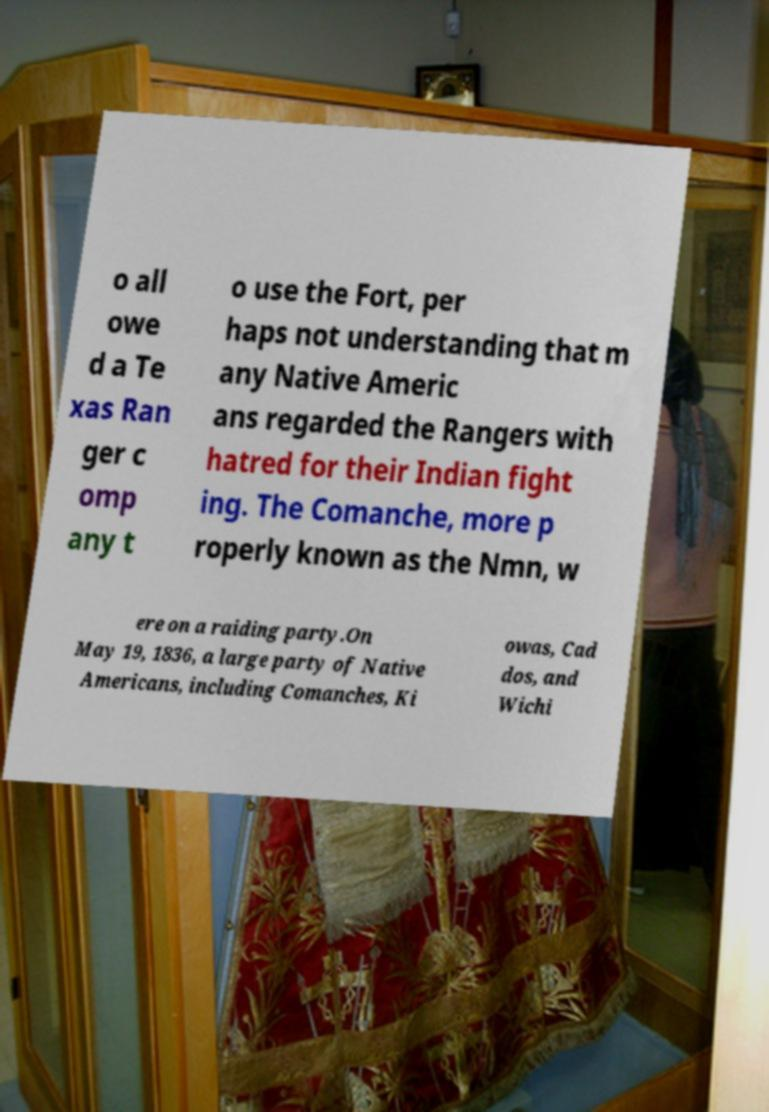What messages or text are displayed in this image? I need them in a readable, typed format. o all owe d a Te xas Ran ger c omp any t o use the Fort, per haps not understanding that m any Native Americ ans regarded the Rangers with hatred for their Indian fight ing. The Comanche, more p roperly known as the Nmn, w ere on a raiding party.On May 19, 1836, a large party of Native Americans, including Comanches, Ki owas, Cad dos, and Wichi 